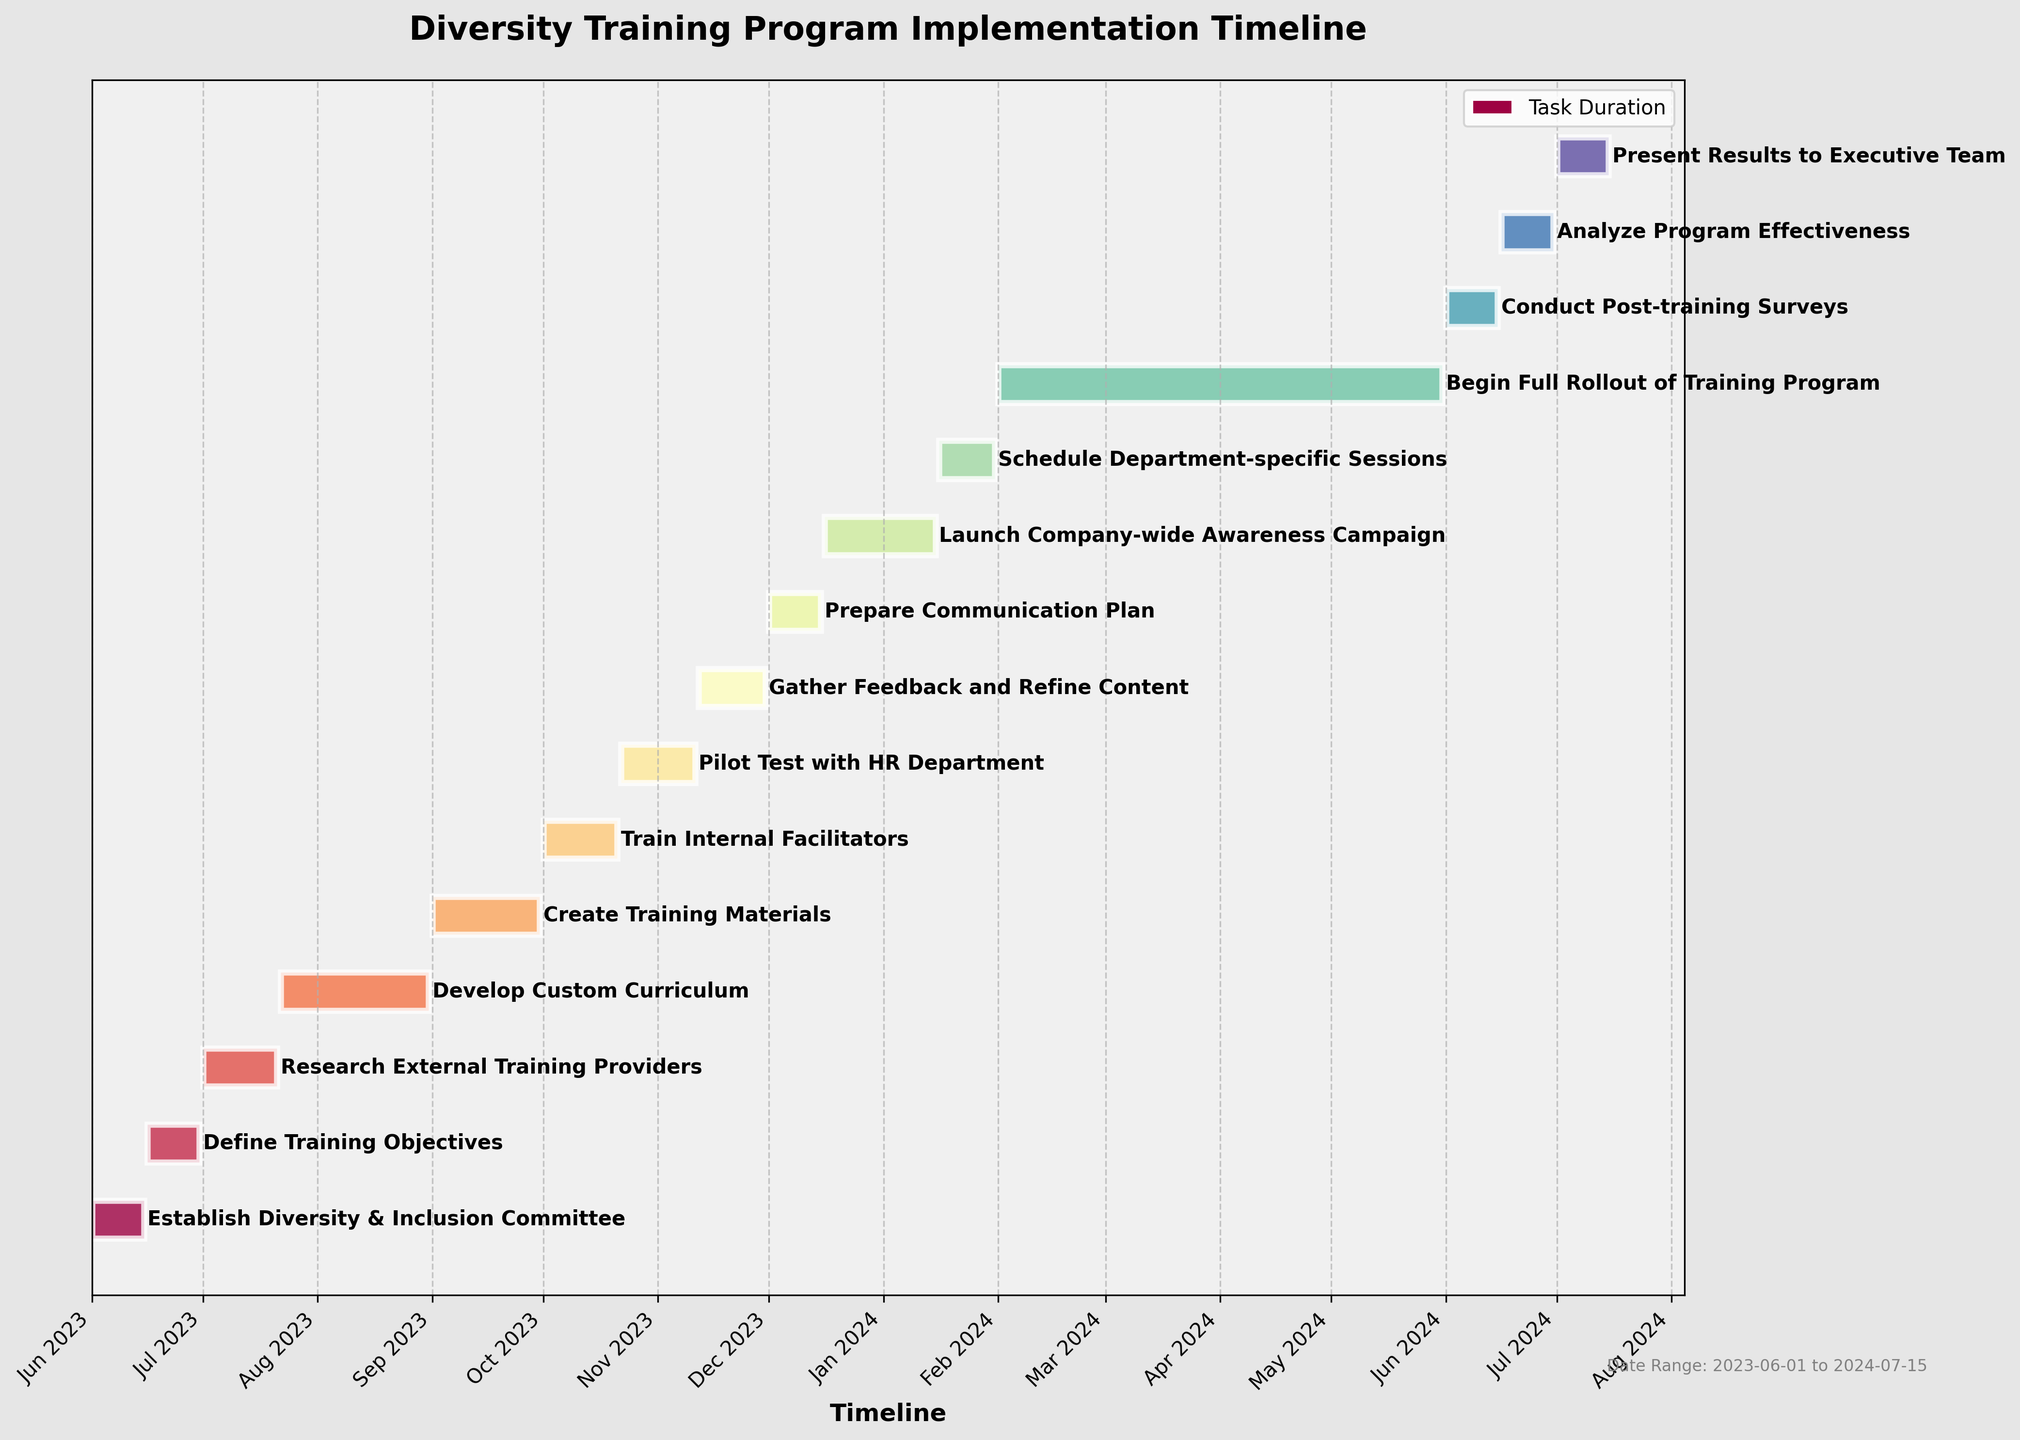What is the title of the Gantt Chart? The title is usually located at the top of the chart. In this case, it reads "Diversity Training Program Implementation Timeline"
Answer: Diversity Training Program Implementation Timeline What is the timeline for creating the training materials? From the horizontal bars, find the bar labeled "Create Training Materials" and identify its start and end dates. The specific dates are visible beside the bar.
Answer: 2023-09-01 to 2023-09-30 Which task takes the longest time to complete? Examine the length of all horizontal bars on the chart. The longer the bar, the longer the task duration. The "Begin Full Rollout of Training Program" bar is the longest, indicating it takes the longest time.
Answer: Begin Full Rollout of Training Program When does the ‘Pilot Test with HR Department’ begin and end? Locate the horizontal bar for "Pilot Test with HR Department" and check the dates at the start and end of the bar.
Answer: 2023-10-22 to 2023-11-11 How many tasks are represented in the Gantt Chart? Count the total number of horizontal bars in the chart. Each bar represents a task.
Answer: 15 Which task is scheduled to end last? Find the rightmost end of the horizontal bars, corresponding to the latest end date. The task "Present Results to Executive Team" ends last.
Answer: Present Results to Executive Team What is the difference in duration between 'Pilot Test with HR Department' and 'Gather Feedback and Refine Content'? Calculate the number of days for each task ("Pilot Test with HR Department": 2023-10-22 to 2023-11-11; "Gather Feedback and Refine Content": 2023-11-12 to 2023-11-30). The first task lasts 20 days and the second 19 days; the difference is 1 day.
Answer: 1 day When does the entire project start and end? Identify the earliest start date and the latest end date on the timeline. The first task starts on 2023-06-01 and the last task ends on 2024-07-15.
Answer: 2023-06-01 to 2024-07-15 Which tasks are scheduled to occur in October 2023? Find the horizontal bars that intersect October 2023 by looking at their start and end dates: "Create Training Materials" ends on 2023-09-30, "Train Internal Facilitators" starts on 2023-10-01, and "Pilot Test with HR Department" starts on 2023-10-22.
Answer: Train Internal Facilitators, Pilot Test with HR Department 